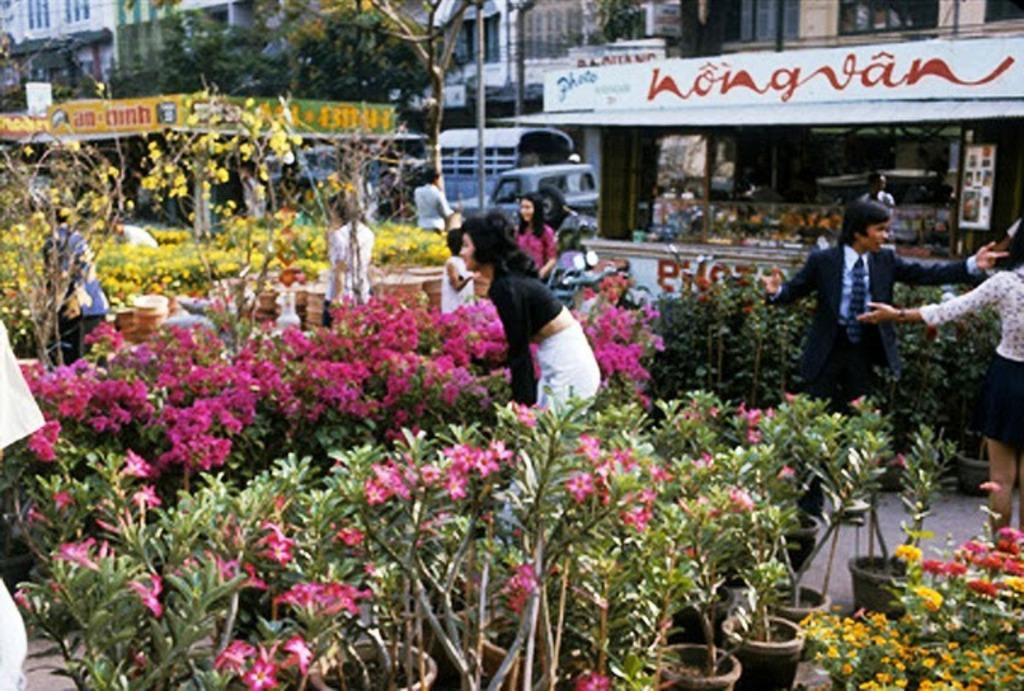What type of structures can be seen in the image? There are buildings in the image. What is happening on the road in the image? Vehicles are moving on the road in the image. Are there any plants visible in the image? Yes, there are potted plants with flowers in the image. Can you see any people in the image? Yes, there are people visible in the image. What type of desk can be seen in the image? There is no desk present in the image. What is the front of the image showing? The provided facts do not mention a "front" of the image, so it is not possible to answer this question. 